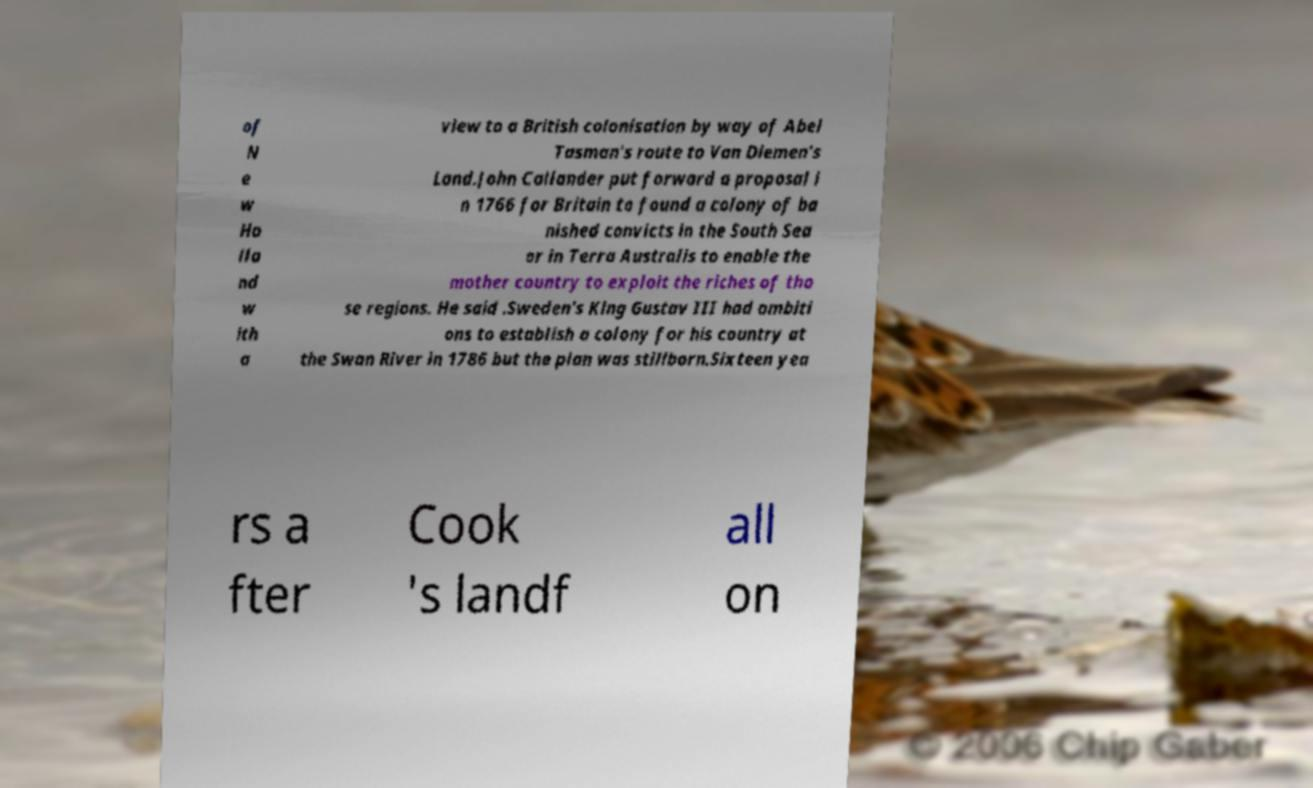What messages or text are displayed in this image? I need them in a readable, typed format. of N e w Ho lla nd w ith a view to a British colonisation by way of Abel Tasman's route to Van Diemen's Land.John Callander put forward a proposal i n 1766 for Britain to found a colony of ba nished convicts in the South Sea or in Terra Australis to enable the mother country to exploit the riches of tho se regions. He said .Sweden's King Gustav III had ambiti ons to establish a colony for his country at the Swan River in 1786 but the plan was stillborn.Sixteen yea rs a fter Cook 's landf all on 